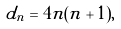Convert formula to latex. <formula><loc_0><loc_0><loc_500><loc_500>d _ { n } = 4 n ( n + 1 ) ,</formula> 